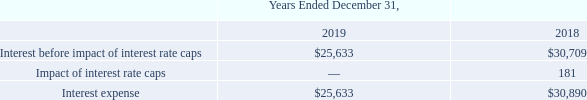INTEREST EXPENSE
The components of interest expense are as follows:
Interest expense, including administrative and other fees, was $25,633 for 2019 compared with $30,890 in 2018. The decrease in interest expense was primarily associated with the impact of the refinancing of our term loan at the end of 2018 and interest capitalized during 2019 due to vessels under construction.
How much was Interest expense, including administrative and other fees for 2019? $25,633. How much was Interest expense, including administrative and other fees for 2018? $30,890. What led to the decrease in interest expense? Primarily associated with the impact of the refinancing of our term loan at the end of 2018 and interest capitalized during 2019 due to vessels under construction. What is the change in Interest before impact of interest rate caps from Years Ended December 31, 2018 to 2019? 25,633-30,709
Answer: -5076. What is the change in Interest expense from Years Ended December 31, 2018 to 2019? 25,633-30,890
Answer: -5257. What is the average Interest before impact of interest rate caps for Years Ended December 31, 2018 to 2019? (25,633+30,709) / 2
Answer: 28171. 